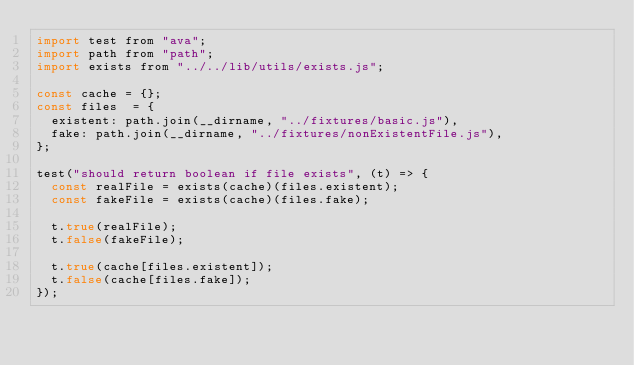<code> <loc_0><loc_0><loc_500><loc_500><_JavaScript_>import test from "ava";
import path from "path";
import exists from "../../lib/utils/exists.js";

const cache = {};
const files  = {
  existent: path.join(__dirname, "../fixtures/basic.js"),
  fake: path.join(__dirname, "../fixtures/nonExistentFile.js"),
};

test("should return boolean if file exists", (t) => {
  const realFile = exists(cache)(files.existent);
  const fakeFile = exists(cache)(files.fake);

  t.true(realFile);
  t.false(fakeFile);

  t.true(cache[files.existent]);
  t.false(cache[files.fake]);
});
</code> 